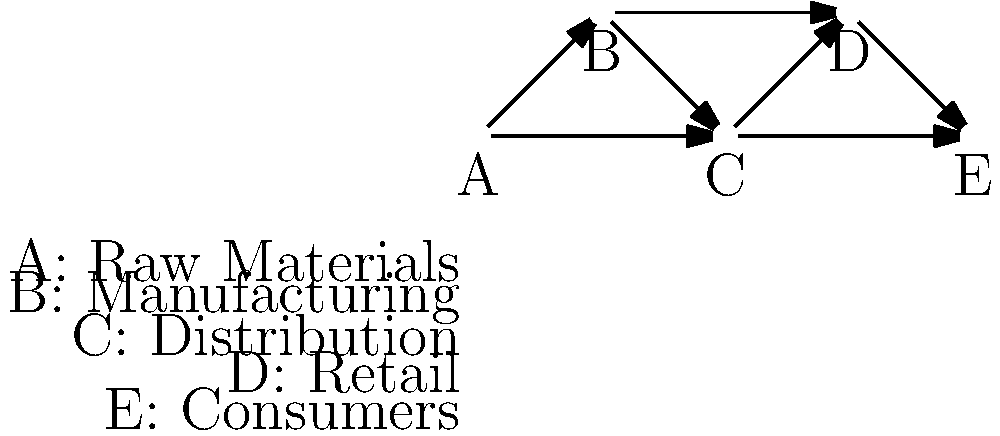Based on the network diagram representing a global supply chain, if trade sanctions are imposed on node B (Manufacturing), which other nodes are likely to experience the most significant direct impact? Explain your reasoning considering the structure of the supply chain. To determine which nodes will experience the most significant direct impact from trade sanctions on node B (Manufacturing), we need to analyze the network structure:

1. Identify direct connections to node B:
   - Node A (Raw Materials) connects directly to B
   - Node C (Distribution) receives input directly from B
   - Node D (Retail) has a direct connection from B

2. Assess the impact on each connected node:
   - Node A: May face reduced demand for raw materials as B's production decreases.
   - Node C: Will likely receive fewer manufactured goods to distribute.
   - Node D: May experience a shortage of products to sell due to reduced manufacturing output.

3. Consider secondary effects:
   - Node E (Consumers) is not directly connected to B but may face indirect effects through reduced product availability at retail (Node D).

4. Evaluate the significance of the impact:
   - Nodes C and D are most dependent on B's output and have fewer alternative connections in the network.
   - Node A has an alternative path to C, potentially mitigating some impact.

5. Conclusion:
   Based on the network structure, Nodes C (Distribution) and D (Retail) are likely to experience the most significant direct impact from sanctions on Node B (Manufacturing) due to their high dependency on B's output and limited alternative supply routes in the given network.
Answer: Nodes C (Distribution) and D (Retail) 